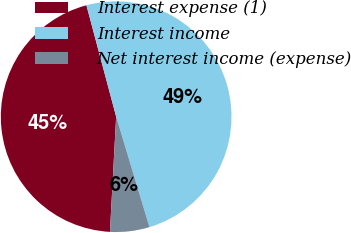Convert chart. <chart><loc_0><loc_0><loc_500><loc_500><pie_chart><fcel>Interest expense (1)<fcel>Interest income<fcel>Net interest income (expense)<nl><fcel>44.99%<fcel>49.49%<fcel>5.52%<nl></chart> 